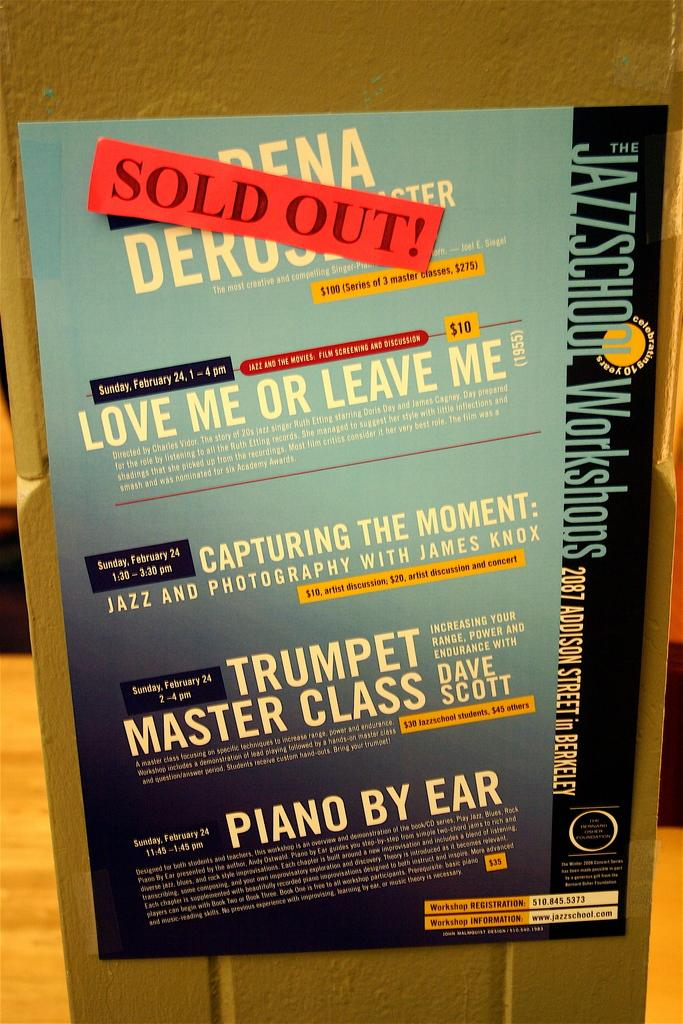Provide a one-sentence caption for the provided image. Sold out show of a jazz school work shop. 